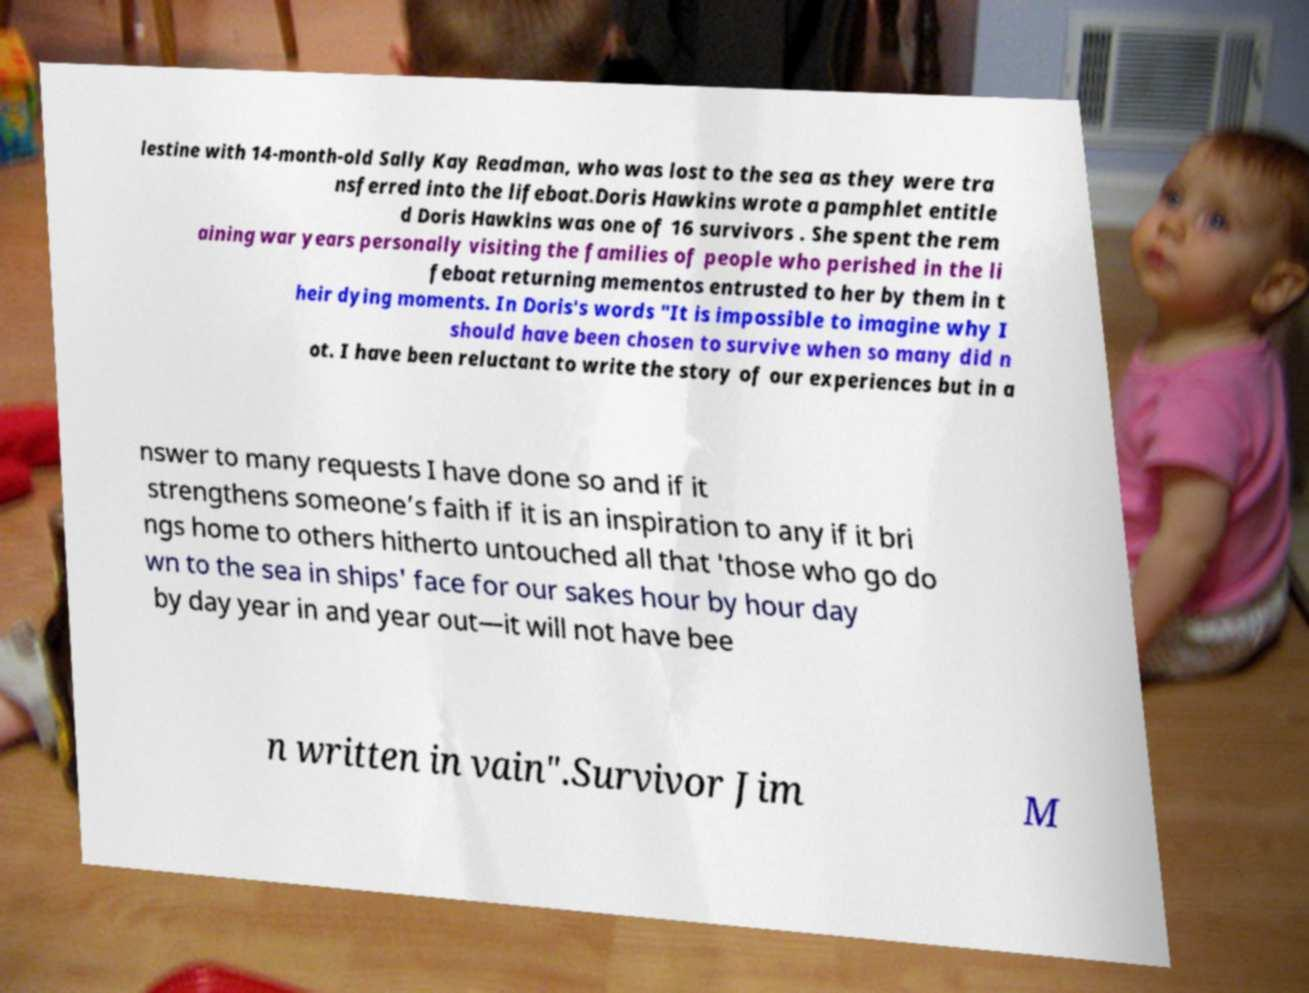Can you accurately transcribe the text from the provided image for me? lestine with 14-month-old Sally Kay Readman, who was lost to the sea as they were tra nsferred into the lifeboat.Doris Hawkins wrote a pamphlet entitle d Doris Hawkins was one of 16 survivors . She spent the rem aining war years personally visiting the families of people who perished in the li feboat returning mementos entrusted to her by them in t heir dying moments. In Doris's words "It is impossible to imagine why I should have been chosen to survive when so many did n ot. I have been reluctant to write the story of our experiences but in a nswer to many requests I have done so and if it strengthens someone’s faith if it is an inspiration to any if it bri ngs home to others hitherto untouched all that 'those who go do wn to the sea in ships' face for our sakes hour by hour day by day year in and year out—it will not have bee n written in vain".Survivor Jim M 